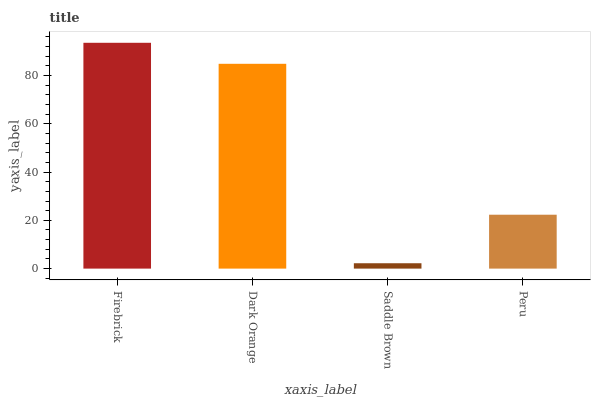Is Saddle Brown the minimum?
Answer yes or no. Yes. Is Firebrick the maximum?
Answer yes or no. Yes. Is Dark Orange the minimum?
Answer yes or no. No. Is Dark Orange the maximum?
Answer yes or no. No. Is Firebrick greater than Dark Orange?
Answer yes or no. Yes. Is Dark Orange less than Firebrick?
Answer yes or no. Yes. Is Dark Orange greater than Firebrick?
Answer yes or no. No. Is Firebrick less than Dark Orange?
Answer yes or no. No. Is Dark Orange the high median?
Answer yes or no. Yes. Is Peru the low median?
Answer yes or no. Yes. Is Firebrick the high median?
Answer yes or no. No. Is Firebrick the low median?
Answer yes or no. No. 